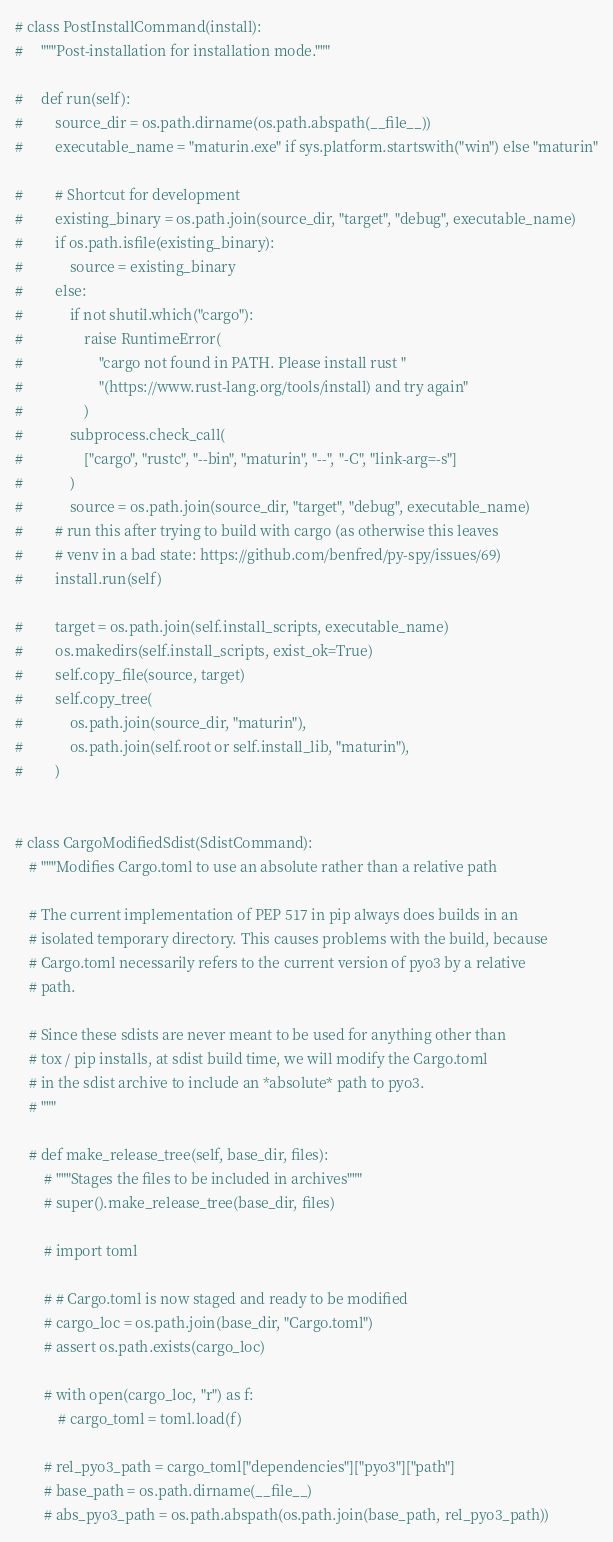Convert code to text. <code><loc_0><loc_0><loc_500><loc_500><_Python_># class PostInstallCommand(install):
#     """Post-installation for installation mode."""

#     def run(self):
#         source_dir = os.path.dirname(os.path.abspath(__file__))
#         executable_name = "maturin.exe" if sys.platform.startswith("win") else "maturin"

#         # Shortcut for development
#         existing_binary = os.path.join(source_dir, "target", "debug", executable_name)
#         if os.path.isfile(existing_binary):
#             source = existing_binary
#         else:
#             if not shutil.which("cargo"):
#                 raise RuntimeError(
#                     "cargo not found in PATH. Please install rust "
#                     "(https://www.rust-lang.org/tools/install) and try again"
#                 )
#             subprocess.check_call(
#                 ["cargo", "rustc", "--bin", "maturin", "--", "-C", "link-arg=-s"]
#             )
#             source = os.path.join(source_dir, "target", "debug", executable_name)
#         # run this after trying to build with cargo (as otherwise this leaves
#         # venv in a bad state: https://github.com/benfred/py-spy/issues/69)
#         install.run(self)

#         target = os.path.join(self.install_scripts, executable_name)
#         os.makedirs(self.install_scripts, exist_ok=True)
#         self.copy_file(source, target)
#         self.copy_tree(
#             os.path.join(source_dir, "maturin"),
#             os.path.join(self.root or self.install_lib, "maturin"),
#         )


# class CargoModifiedSdist(SdistCommand):
    # """Modifies Cargo.toml to use an absolute rather than a relative path

    # The current implementation of PEP 517 in pip always does builds in an
    # isolated temporary directory. This causes problems with the build, because
    # Cargo.toml necessarily refers to the current version of pyo3 by a relative
    # path.

    # Since these sdists are never meant to be used for anything other than
    # tox / pip installs, at sdist build time, we will modify the Cargo.toml
    # in the sdist archive to include an *absolute* path to pyo3.
    # """

    # def make_release_tree(self, base_dir, files):
        # """Stages the files to be included in archives"""
        # super().make_release_tree(base_dir, files)

        # import toml

        # # Cargo.toml is now staged and ready to be modified
        # cargo_loc = os.path.join(base_dir, "Cargo.toml")
        # assert os.path.exists(cargo_loc)

        # with open(cargo_loc, "r") as f:
            # cargo_toml = toml.load(f)

        # rel_pyo3_path = cargo_toml["dependencies"]["pyo3"]["path"]
        # base_path = os.path.dirname(__file__)
        # abs_pyo3_path = os.path.abspath(os.path.join(base_path, rel_pyo3_path))
</code> 